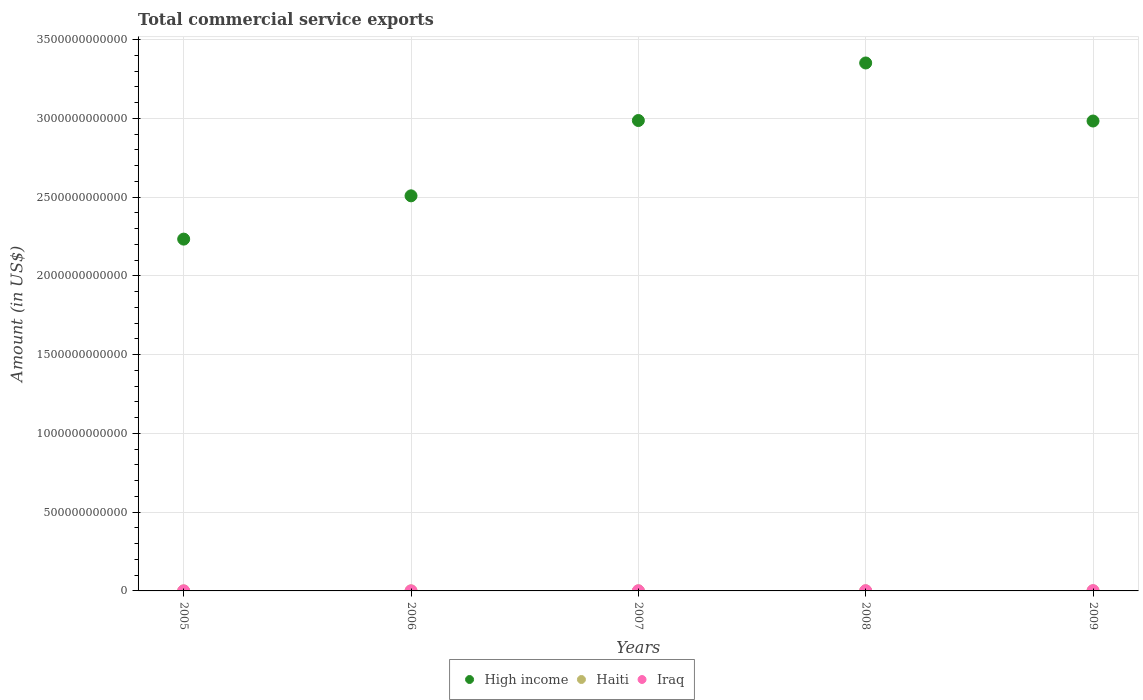What is the total commercial service exports in Iraq in 2009?
Offer a very short reply. 1.73e+09. Across all years, what is the maximum total commercial service exports in Haiti?
Provide a succinct answer. 4.29e+08. Across all years, what is the minimum total commercial service exports in Iraq?
Your answer should be compact. 3.48e+08. In which year was the total commercial service exports in High income minimum?
Offer a very short reply. 2005. What is the total total commercial service exports in Iraq in the graph?
Your answer should be compact. 4.52e+09. What is the difference between the total commercial service exports in Iraq in 2005 and that in 2008?
Your response must be concise. -9.02e+08. What is the difference between the total commercial service exports in High income in 2008 and the total commercial service exports in Haiti in 2009?
Provide a short and direct response. 3.35e+12. What is the average total commercial service exports in Iraq per year?
Keep it short and to the point. 9.04e+08. In the year 2007, what is the difference between the total commercial service exports in High income and total commercial service exports in Haiti?
Keep it short and to the point. 2.99e+12. In how many years, is the total commercial service exports in High income greater than 300000000000 US$?
Give a very brief answer. 5. What is the ratio of the total commercial service exports in High income in 2005 to that in 2009?
Your answer should be compact. 0.75. What is the difference between the highest and the second highest total commercial service exports in Haiti?
Offer a very short reply. 5.60e+07. What is the difference between the highest and the lowest total commercial service exports in Haiti?
Keep it short and to the point. 3.35e+08. Is the sum of the total commercial service exports in Haiti in 2007 and 2009 greater than the maximum total commercial service exports in Iraq across all years?
Keep it short and to the point. No. Is the total commercial service exports in Iraq strictly greater than the total commercial service exports in Haiti over the years?
Give a very brief answer. Yes. Is the total commercial service exports in Iraq strictly less than the total commercial service exports in Haiti over the years?
Keep it short and to the point. No. What is the difference between two consecutive major ticks on the Y-axis?
Offer a very short reply. 5.00e+11. Does the graph contain any zero values?
Your response must be concise. No. How many legend labels are there?
Make the answer very short. 3. What is the title of the graph?
Make the answer very short. Total commercial service exports. Does "St. Lucia" appear as one of the legend labels in the graph?
Offer a terse response. No. What is the Amount (in US$) in High income in 2005?
Offer a very short reply. 2.23e+12. What is the Amount (in US$) of Haiti in 2005?
Your response must be concise. 9.33e+07. What is the Amount (in US$) in Iraq in 2005?
Your answer should be very brief. 3.48e+08. What is the Amount (in US$) in High income in 2006?
Give a very brief answer. 2.51e+12. What is the Amount (in US$) in Haiti in 2006?
Provide a short and direct response. 1.40e+08. What is the Amount (in US$) of Iraq in 2006?
Provide a short and direct response. 3.53e+08. What is the Amount (in US$) in High income in 2007?
Your response must be concise. 2.99e+12. What is the Amount (in US$) in Haiti in 2007?
Make the answer very short. 2.03e+08. What is the Amount (in US$) of Iraq in 2007?
Keep it short and to the point. 8.39e+08. What is the Amount (in US$) in High income in 2008?
Keep it short and to the point. 3.35e+12. What is the Amount (in US$) in Haiti in 2008?
Make the answer very short. 3.73e+08. What is the Amount (in US$) of Iraq in 2008?
Make the answer very short. 1.25e+09. What is the Amount (in US$) in High income in 2009?
Your response must be concise. 2.98e+12. What is the Amount (in US$) in Haiti in 2009?
Your answer should be compact. 4.29e+08. What is the Amount (in US$) of Iraq in 2009?
Your answer should be very brief. 1.73e+09. Across all years, what is the maximum Amount (in US$) in High income?
Make the answer very short. 3.35e+12. Across all years, what is the maximum Amount (in US$) of Haiti?
Your response must be concise. 4.29e+08. Across all years, what is the maximum Amount (in US$) in Iraq?
Make the answer very short. 1.73e+09. Across all years, what is the minimum Amount (in US$) in High income?
Keep it short and to the point. 2.23e+12. Across all years, what is the minimum Amount (in US$) in Haiti?
Ensure brevity in your answer.  9.33e+07. Across all years, what is the minimum Amount (in US$) of Iraq?
Provide a short and direct response. 3.48e+08. What is the total Amount (in US$) of High income in the graph?
Keep it short and to the point. 1.41e+13. What is the total Amount (in US$) of Haiti in the graph?
Give a very brief answer. 1.24e+09. What is the total Amount (in US$) in Iraq in the graph?
Provide a succinct answer. 4.52e+09. What is the difference between the Amount (in US$) in High income in 2005 and that in 2006?
Provide a short and direct response. -2.75e+11. What is the difference between the Amount (in US$) of Haiti in 2005 and that in 2006?
Keep it short and to the point. -4.63e+07. What is the difference between the Amount (in US$) of Iraq in 2005 and that in 2006?
Your answer should be very brief. -5.80e+06. What is the difference between the Amount (in US$) in High income in 2005 and that in 2007?
Your answer should be compact. -7.53e+11. What is the difference between the Amount (in US$) in Haiti in 2005 and that in 2007?
Give a very brief answer. -1.09e+08. What is the difference between the Amount (in US$) in Iraq in 2005 and that in 2007?
Make the answer very short. -4.92e+08. What is the difference between the Amount (in US$) of High income in 2005 and that in 2008?
Offer a very short reply. -1.12e+12. What is the difference between the Amount (in US$) of Haiti in 2005 and that in 2008?
Keep it short and to the point. -2.79e+08. What is the difference between the Amount (in US$) of Iraq in 2005 and that in 2008?
Provide a short and direct response. -9.02e+08. What is the difference between the Amount (in US$) in High income in 2005 and that in 2009?
Offer a terse response. -7.50e+11. What is the difference between the Amount (in US$) in Haiti in 2005 and that in 2009?
Offer a very short reply. -3.35e+08. What is the difference between the Amount (in US$) in Iraq in 2005 and that in 2009?
Your answer should be very brief. -1.38e+09. What is the difference between the Amount (in US$) in High income in 2006 and that in 2007?
Your answer should be compact. -4.78e+11. What is the difference between the Amount (in US$) in Haiti in 2006 and that in 2007?
Keep it short and to the point. -6.32e+07. What is the difference between the Amount (in US$) in Iraq in 2006 and that in 2007?
Provide a short and direct response. -4.86e+08. What is the difference between the Amount (in US$) in High income in 2006 and that in 2008?
Your answer should be very brief. -8.44e+11. What is the difference between the Amount (in US$) of Haiti in 2006 and that in 2008?
Give a very brief answer. -2.33e+08. What is the difference between the Amount (in US$) of Iraq in 2006 and that in 2008?
Your response must be concise. -8.96e+08. What is the difference between the Amount (in US$) in High income in 2006 and that in 2009?
Your answer should be compact. -4.75e+11. What is the difference between the Amount (in US$) of Haiti in 2006 and that in 2009?
Keep it short and to the point. -2.89e+08. What is the difference between the Amount (in US$) in Iraq in 2006 and that in 2009?
Your response must be concise. -1.38e+09. What is the difference between the Amount (in US$) in High income in 2007 and that in 2008?
Your answer should be very brief. -3.65e+11. What is the difference between the Amount (in US$) in Haiti in 2007 and that in 2008?
Offer a terse response. -1.70e+08. What is the difference between the Amount (in US$) of Iraq in 2007 and that in 2008?
Make the answer very short. -4.10e+08. What is the difference between the Amount (in US$) of High income in 2007 and that in 2009?
Offer a terse response. 3.19e+09. What is the difference between the Amount (in US$) in Haiti in 2007 and that in 2009?
Your answer should be very brief. -2.26e+08. What is the difference between the Amount (in US$) of Iraq in 2007 and that in 2009?
Your answer should be very brief. -8.91e+08. What is the difference between the Amount (in US$) of High income in 2008 and that in 2009?
Provide a succinct answer. 3.69e+11. What is the difference between the Amount (in US$) of Haiti in 2008 and that in 2009?
Your answer should be very brief. -5.60e+07. What is the difference between the Amount (in US$) of Iraq in 2008 and that in 2009?
Make the answer very short. -4.81e+08. What is the difference between the Amount (in US$) of High income in 2005 and the Amount (in US$) of Haiti in 2006?
Offer a terse response. 2.23e+12. What is the difference between the Amount (in US$) in High income in 2005 and the Amount (in US$) in Iraq in 2006?
Give a very brief answer. 2.23e+12. What is the difference between the Amount (in US$) of Haiti in 2005 and the Amount (in US$) of Iraq in 2006?
Your response must be concise. -2.60e+08. What is the difference between the Amount (in US$) of High income in 2005 and the Amount (in US$) of Haiti in 2007?
Make the answer very short. 2.23e+12. What is the difference between the Amount (in US$) of High income in 2005 and the Amount (in US$) of Iraq in 2007?
Your response must be concise. 2.23e+12. What is the difference between the Amount (in US$) in Haiti in 2005 and the Amount (in US$) in Iraq in 2007?
Provide a short and direct response. -7.46e+08. What is the difference between the Amount (in US$) in High income in 2005 and the Amount (in US$) in Haiti in 2008?
Offer a terse response. 2.23e+12. What is the difference between the Amount (in US$) in High income in 2005 and the Amount (in US$) in Iraq in 2008?
Your answer should be very brief. 2.23e+12. What is the difference between the Amount (in US$) of Haiti in 2005 and the Amount (in US$) of Iraq in 2008?
Offer a terse response. -1.16e+09. What is the difference between the Amount (in US$) in High income in 2005 and the Amount (in US$) in Haiti in 2009?
Provide a short and direct response. 2.23e+12. What is the difference between the Amount (in US$) of High income in 2005 and the Amount (in US$) of Iraq in 2009?
Give a very brief answer. 2.23e+12. What is the difference between the Amount (in US$) of Haiti in 2005 and the Amount (in US$) of Iraq in 2009?
Keep it short and to the point. -1.64e+09. What is the difference between the Amount (in US$) of High income in 2006 and the Amount (in US$) of Haiti in 2007?
Your answer should be very brief. 2.51e+12. What is the difference between the Amount (in US$) in High income in 2006 and the Amount (in US$) in Iraq in 2007?
Keep it short and to the point. 2.51e+12. What is the difference between the Amount (in US$) of Haiti in 2006 and the Amount (in US$) of Iraq in 2007?
Make the answer very short. -7.00e+08. What is the difference between the Amount (in US$) in High income in 2006 and the Amount (in US$) in Haiti in 2008?
Your answer should be compact. 2.51e+12. What is the difference between the Amount (in US$) in High income in 2006 and the Amount (in US$) in Iraq in 2008?
Offer a terse response. 2.51e+12. What is the difference between the Amount (in US$) in Haiti in 2006 and the Amount (in US$) in Iraq in 2008?
Offer a terse response. -1.11e+09. What is the difference between the Amount (in US$) of High income in 2006 and the Amount (in US$) of Haiti in 2009?
Your response must be concise. 2.51e+12. What is the difference between the Amount (in US$) of High income in 2006 and the Amount (in US$) of Iraq in 2009?
Ensure brevity in your answer.  2.51e+12. What is the difference between the Amount (in US$) in Haiti in 2006 and the Amount (in US$) in Iraq in 2009?
Offer a very short reply. -1.59e+09. What is the difference between the Amount (in US$) in High income in 2007 and the Amount (in US$) in Haiti in 2008?
Offer a terse response. 2.99e+12. What is the difference between the Amount (in US$) of High income in 2007 and the Amount (in US$) of Iraq in 2008?
Make the answer very short. 2.99e+12. What is the difference between the Amount (in US$) of Haiti in 2007 and the Amount (in US$) of Iraq in 2008?
Your answer should be very brief. -1.05e+09. What is the difference between the Amount (in US$) of High income in 2007 and the Amount (in US$) of Haiti in 2009?
Offer a very short reply. 2.99e+12. What is the difference between the Amount (in US$) of High income in 2007 and the Amount (in US$) of Iraq in 2009?
Ensure brevity in your answer.  2.99e+12. What is the difference between the Amount (in US$) of Haiti in 2007 and the Amount (in US$) of Iraq in 2009?
Give a very brief answer. -1.53e+09. What is the difference between the Amount (in US$) of High income in 2008 and the Amount (in US$) of Haiti in 2009?
Your answer should be compact. 3.35e+12. What is the difference between the Amount (in US$) in High income in 2008 and the Amount (in US$) in Iraq in 2009?
Make the answer very short. 3.35e+12. What is the difference between the Amount (in US$) of Haiti in 2008 and the Amount (in US$) of Iraq in 2009?
Your answer should be very brief. -1.36e+09. What is the average Amount (in US$) of High income per year?
Make the answer very short. 2.81e+12. What is the average Amount (in US$) in Haiti per year?
Offer a terse response. 2.47e+08. What is the average Amount (in US$) in Iraq per year?
Provide a short and direct response. 9.04e+08. In the year 2005, what is the difference between the Amount (in US$) of High income and Amount (in US$) of Haiti?
Your answer should be compact. 2.23e+12. In the year 2005, what is the difference between the Amount (in US$) in High income and Amount (in US$) in Iraq?
Provide a short and direct response. 2.23e+12. In the year 2005, what is the difference between the Amount (in US$) in Haiti and Amount (in US$) in Iraq?
Provide a short and direct response. -2.54e+08. In the year 2006, what is the difference between the Amount (in US$) in High income and Amount (in US$) in Haiti?
Provide a short and direct response. 2.51e+12. In the year 2006, what is the difference between the Amount (in US$) of High income and Amount (in US$) of Iraq?
Your answer should be very brief. 2.51e+12. In the year 2006, what is the difference between the Amount (in US$) of Haiti and Amount (in US$) of Iraq?
Your answer should be very brief. -2.14e+08. In the year 2007, what is the difference between the Amount (in US$) of High income and Amount (in US$) of Haiti?
Make the answer very short. 2.99e+12. In the year 2007, what is the difference between the Amount (in US$) in High income and Amount (in US$) in Iraq?
Provide a short and direct response. 2.99e+12. In the year 2007, what is the difference between the Amount (in US$) in Haiti and Amount (in US$) in Iraq?
Ensure brevity in your answer.  -6.36e+08. In the year 2008, what is the difference between the Amount (in US$) of High income and Amount (in US$) of Haiti?
Provide a succinct answer. 3.35e+12. In the year 2008, what is the difference between the Amount (in US$) in High income and Amount (in US$) in Iraq?
Your response must be concise. 3.35e+12. In the year 2008, what is the difference between the Amount (in US$) in Haiti and Amount (in US$) in Iraq?
Ensure brevity in your answer.  -8.76e+08. In the year 2009, what is the difference between the Amount (in US$) of High income and Amount (in US$) of Haiti?
Give a very brief answer. 2.98e+12. In the year 2009, what is the difference between the Amount (in US$) in High income and Amount (in US$) in Iraq?
Your answer should be compact. 2.98e+12. In the year 2009, what is the difference between the Amount (in US$) of Haiti and Amount (in US$) of Iraq?
Keep it short and to the point. -1.30e+09. What is the ratio of the Amount (in US$) of High income in 2005 to that in 2006?
Give a very brief answer. 0.89. What is the ratio of the Amount (in US$) in Haiti in 2005 to that in 2006?
Make the answer very short. 0.67. What is the ratio of the Amount (in US$) of Iraq in 2005 to that in 2006?
Ensure brevity in your answer.  0.98. What is the ratio of the Amount (in US$) of High income in 2005 to that in 2007?
Your answer should be very brief. 0.75. What is the ratio of the Amount (in US$) of Haiti in 2005 to that in 2007?
Your response must be concise. 0.46. What is the ratio of the Amount (in US$) of Iraq in 2005 to that in 2007?
Make the answer very short. 0.41. What is the ratio of the Amount (in US$) of High income in 2005 to that in 2008?
Offer a terse response. 0.67. What is the ratio of the Amount (in US$) in Haiti in 2005 to that in 2008?
Your answer should be very brief. 0.25. What is the ratio of the Amount (in US$) in Iraq in 2005 to that in 2008?
Your answer should be compact. 0.28. What is the ratio of the Amount (in US$) in High income in 2005 to that in 2009?
Your answer should be very brief. 0.75. What is the ratio of the Amount (in US$) in Haiti in 2005 to that in 2009?
Offer a very short reply. 0.22. What is the ratio of the Amount (in US$) of Iraq in 2005 to that in 2009?
Provide a succinct answer. 0.2. What is the ratio of the Amount (in US$) in High income in 2006 to that in 2007?
Provide a succinct answer. 0.84. What is the ratio of the Amount (in US$) of Haiti in 2006 to that in 2007?
Give a very brief answer. 0.69. What is the ratio of the Amount (in US$) in Iraq in 2006 to that in 2007?
Your response must be concise. 0.42. What is the ratio of the Amount (in US$) in High income in 2006 to that in 2008?
Your response must be concise. 0.75. What is the ratio of the Amount (in US$) in Haiti in 2006 to that in 2008?
Keep it short and to the point. 0.37. What is the ratio of the Amount (in US$) in Iraq in 2006 to that in 2008?
Keep it short and to the point. 0.28. What is the ratio of the Amount (in US$) of High income in 2006 to that in 2009?
Ensure brevity in your answer.  0.84. What is the ratio of the Amount (in US$) of Haiti in 2006 to that in 2009?
Your answer should be very brief. 0.33. What is the ratio of the Amount (in US$) of Iraq in 2006 to that in 2009?
Ensure brevity in your answer.  0.2. What is the ratio of the Amount (in US$) of High income in 2007 to that in 2008?
Offer a very short reply. 0.89. What is the ratio of the Amount (in US$) in Haiti in 2007 to that in 2008?
Make the answer very short. 0.54. What is the ratio of the Amount (in US$) in Iraq in 2007 to that in 2008?
Make the answer very short. 0.67. What is the ratio of the Amount (in US$) of High income in 2007 to that in 2009?
Give a very brief answer. 1. What is the ratio of the Amount (in US$) of Haiti in 2007 to that in 2009?
Keep it short and to the point. 0.47. What is the ratio of the Amount (in US$) in Iraq in 2007 to that in 2009?
Your answer should be very brief. 0.49. What is the ratio of the Amount (in US$) of High income in 2008 to that in 2009?
Your response must be concise. 1.12. What is the ratio of the Amount (in US$) of Haiti in 2008 to that in 2009?
Provide a short and direct response. 0.87. What is the ratio of the Amount (in US$) in Iraq in 2008 to that in 2009?
Offer a terse response. 0.72. What is the difference between the highest and the second highest Amount (in US$) of High income?
Give a very brief answer. 3.65e+11. What is the difference between the highest and the second highest Amount (in US$) of Haiti?
Keep it short and to the point. 5.60e+07. What is the difference between the highest and the second highest Amount (in US$) of Iraq?
Give a very brief answer. 4.81e+08. What is the difference between the highest and the lowest Amount (in US$) of High income?
Your answer should be very brief. 1.12e+12. What is the difference between the highest and the lowest Amount (in US$) in Haiti?
Provide a short and direct response. 3.35e+08. What is the difference between the highest and the lowest Amount (in US$) of Iraq?
Offer a very short reply. 1.38e+09. 